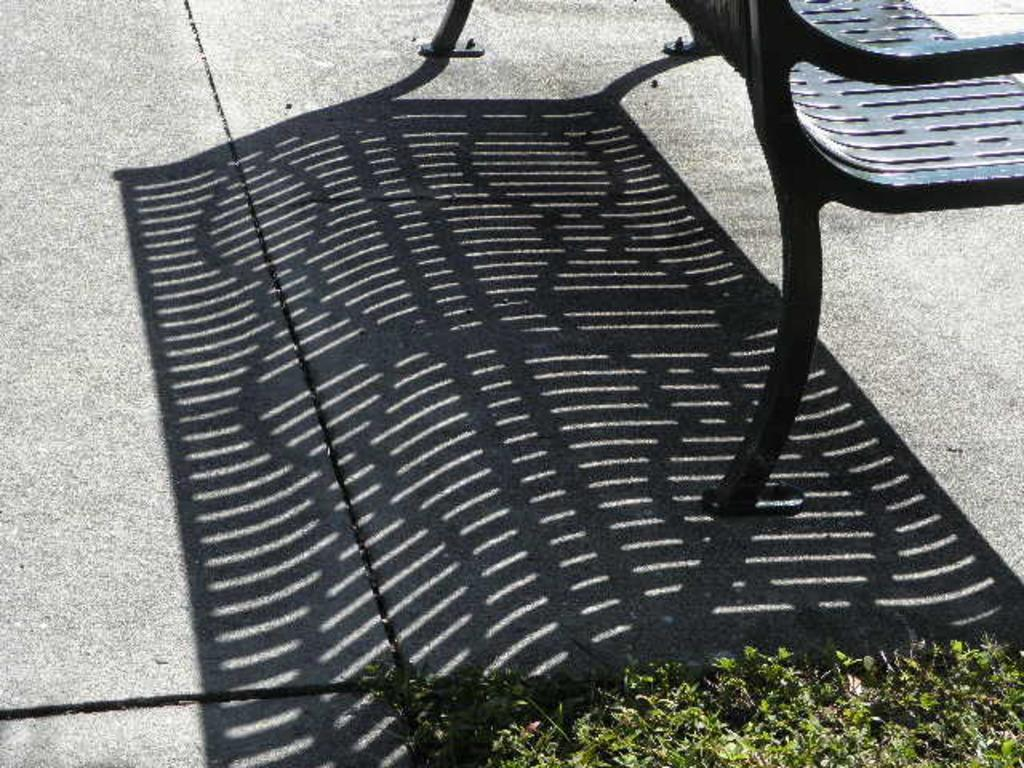Where was the image taken? The image was clicked outside. What can be seen in the foreground of the image? There are plants in the foreground of the image. What is casting a shadow on the ground in the image? There is a shadow of a bench on the ground. Where is the bench located in the image? The bench is placed on the right corner of the image. What line of text can be seen in the image? There is no line of text present in the image. What act are the plants performing in the image? Plants do not perform acts; they are living organisms that grow and produce oxygen. 